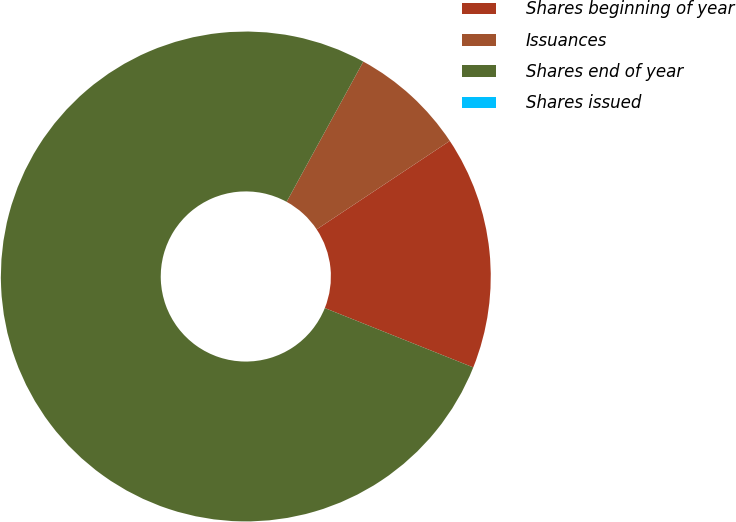Convert chart to OTSL. <chart><loc_0><loc_0><loc_500><loc_500><pie_chart><fcel>Shares beginning of year<fcel>Issuances<fcel>Shares end of year<fcel>Shares issued<nl><fcel>15.39%<fcel>7.7%<fcel>76.91%<fcel>0.0%<nl></chart> 